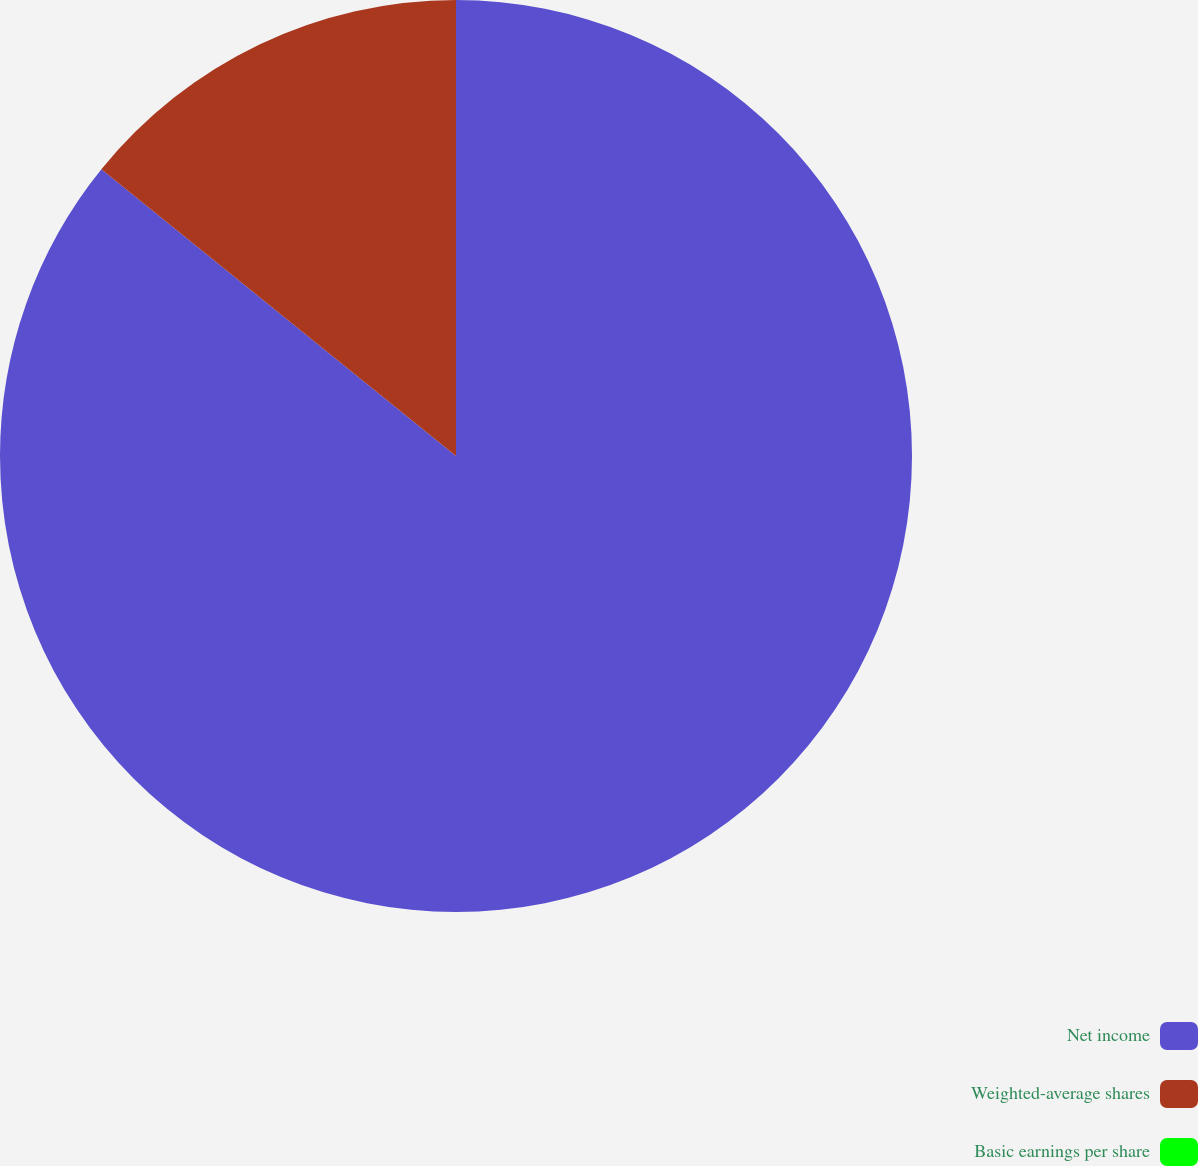<chart> <loc_0><loc_0><loc_500><loc_500><pie_chart><fcel>Net income<fcel>Weighted-average shares<fcel>Basic earnings per share<nl><fcel>85.82%<fcel>14.18%<fcel>0.0%<nl></chart> 